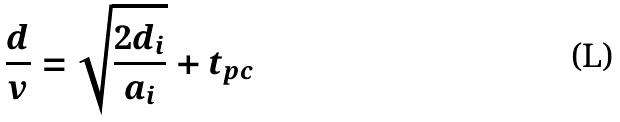Convert formula to latex. <formula><loc_0><loc_0><loc_500><loc_500>\frac { d } { v } = \sqrt { \frac { 2 d _ { i } } { a _ { i } } } + t _ { p c }</formula> 